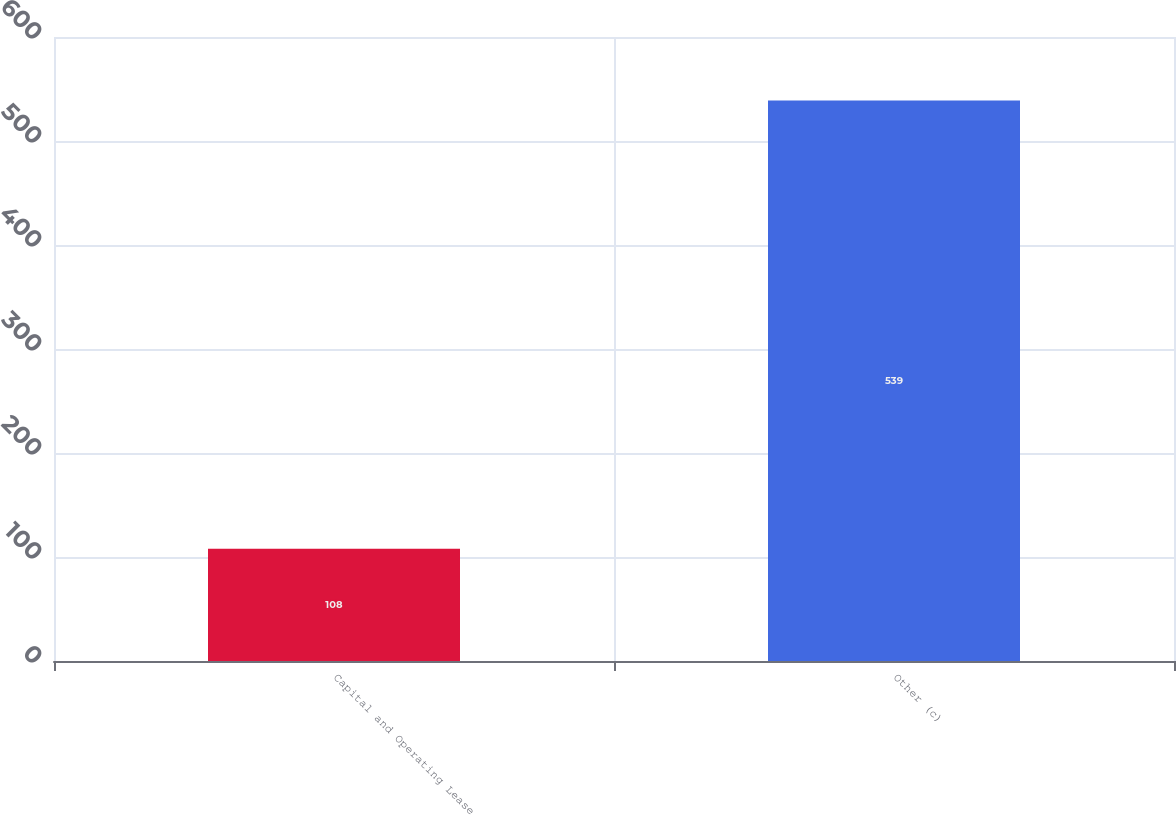Convert chart to OTSL. <chart><loc_0><loc_0><loc_500><loc_500><bar_chart><fcel>Capital and Operating Lease<fcel>Other (c)<nl><fcel>108<fcel>539<nl></chart> 